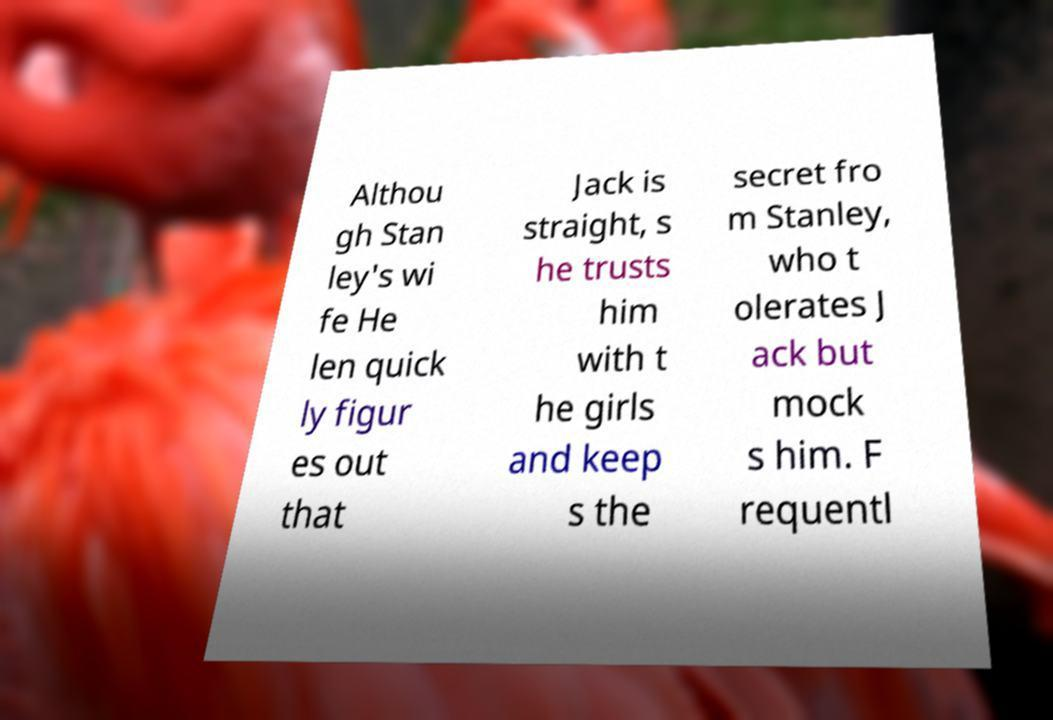I need the written content from this picture converted into text. Can you do that? Althou gh Stan ley's wi fe He len quick ly figur es out that Jack is straight, s he trusts him with t he girls and keep s the secret fro m Stanley, who t olerates J ack but mock s him. F requentl 